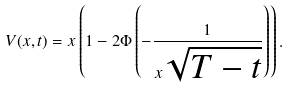<formula> <loc_0><loc_0><loc_500><loc_500>V ( x , t ) = x \left ( 1 - 2 \Phi \left ( - \frac { 1 } { x \sqrt { T - t } } \right ) \right ) .</formula> 